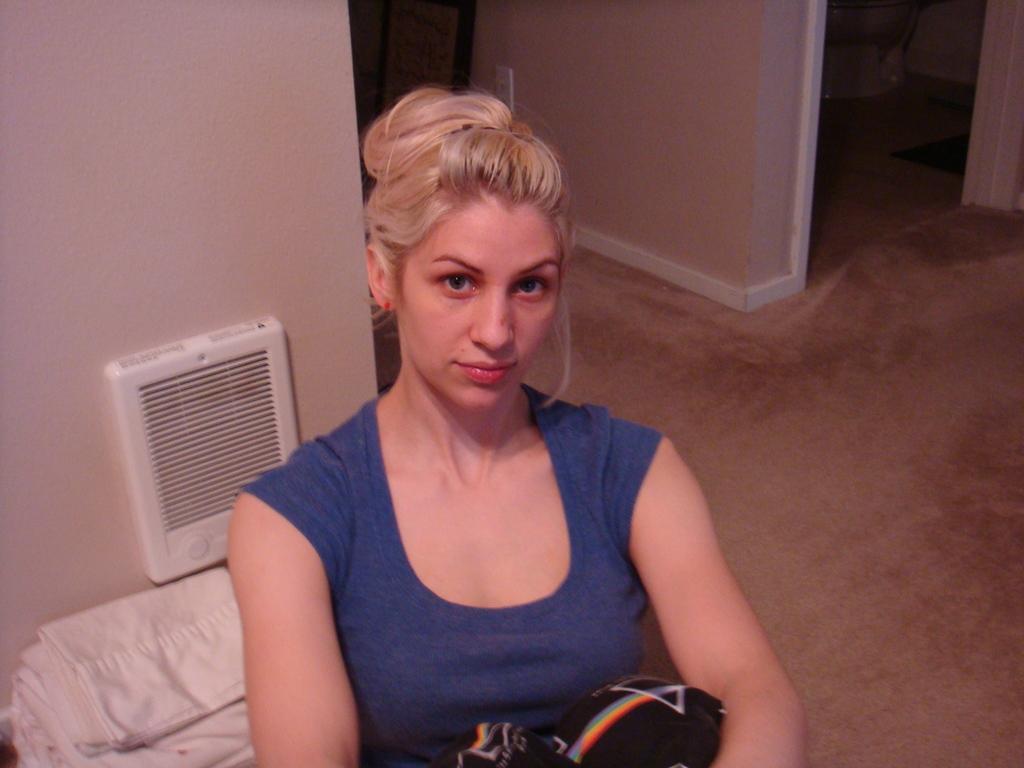Could you give a brief overview of what you see in this image? In this picture we can see a woman wearing a blue t-shirt. Behind to her we can see white clothes. In the background we can see walls and this is a floor. 